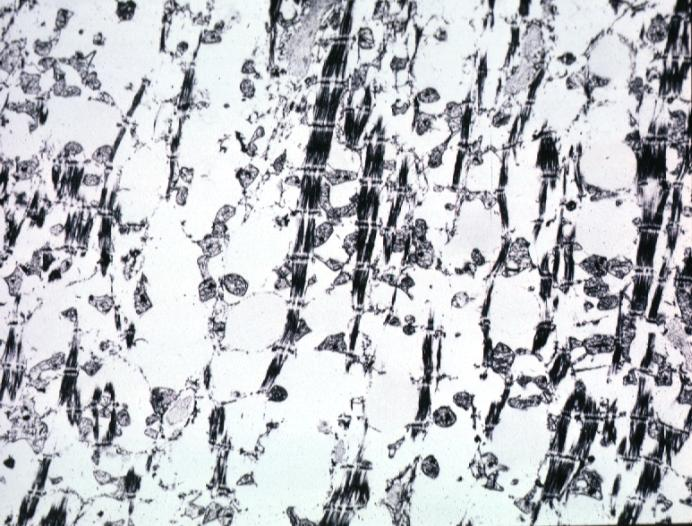does retroperitoneal liposarcoma contain not lipid?
Answer the question using a single word or phrase. No 